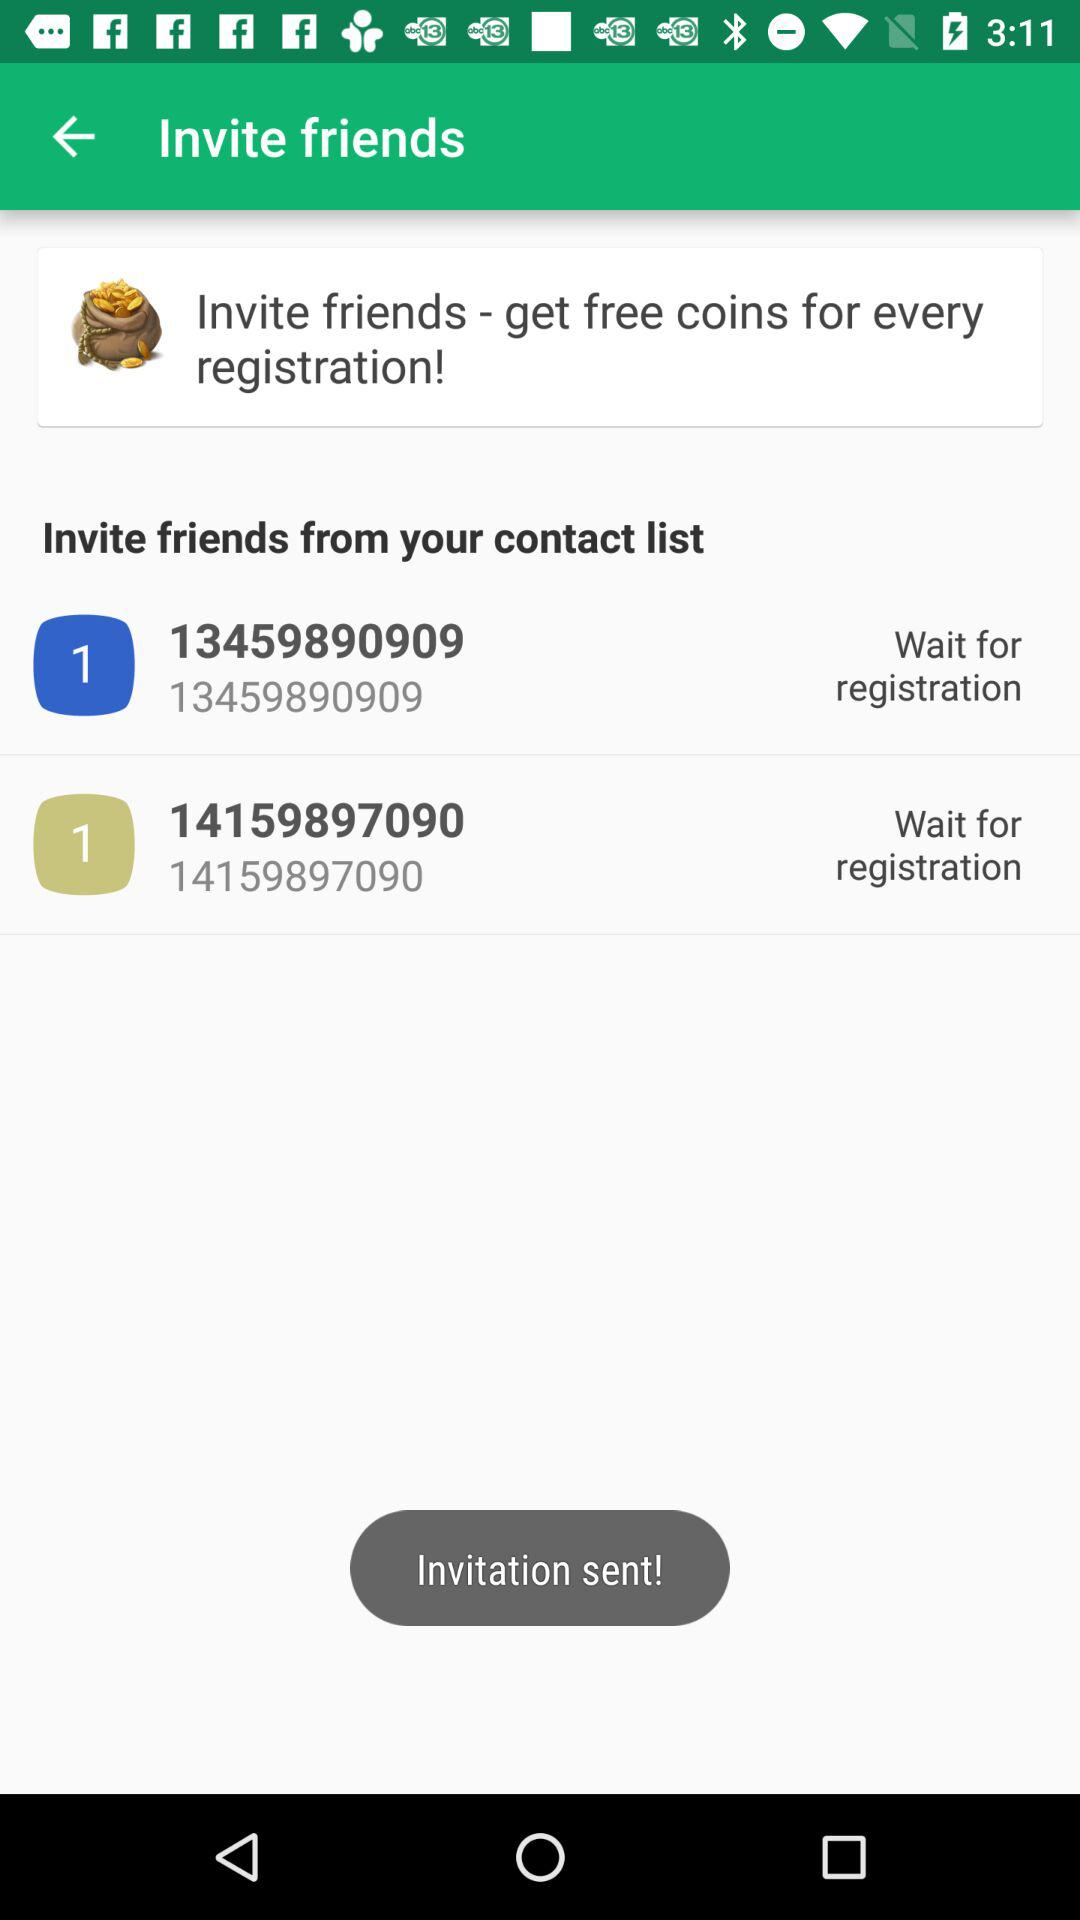How many friends have registration pending?
Answer the question using a single word or phrase. 2 